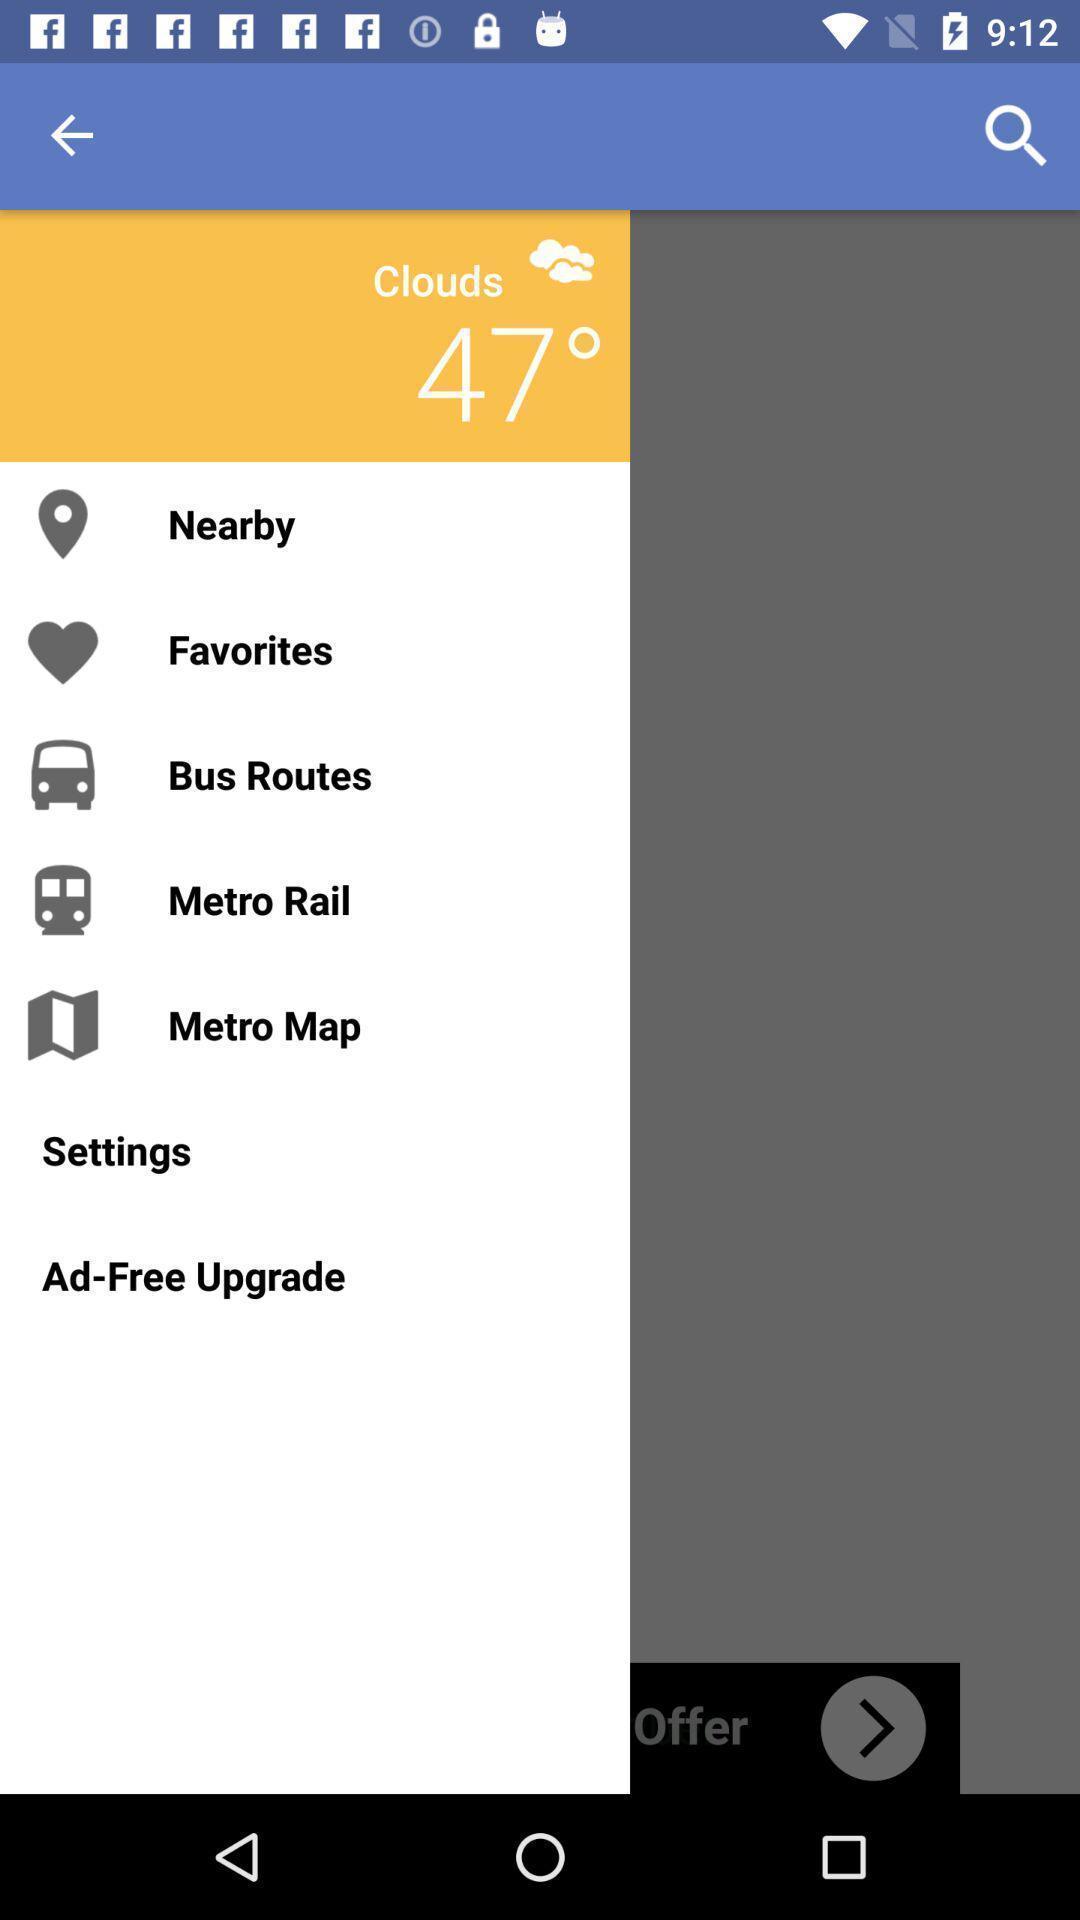Explain the elements present in this screenshot. Settings page of a transit application. 